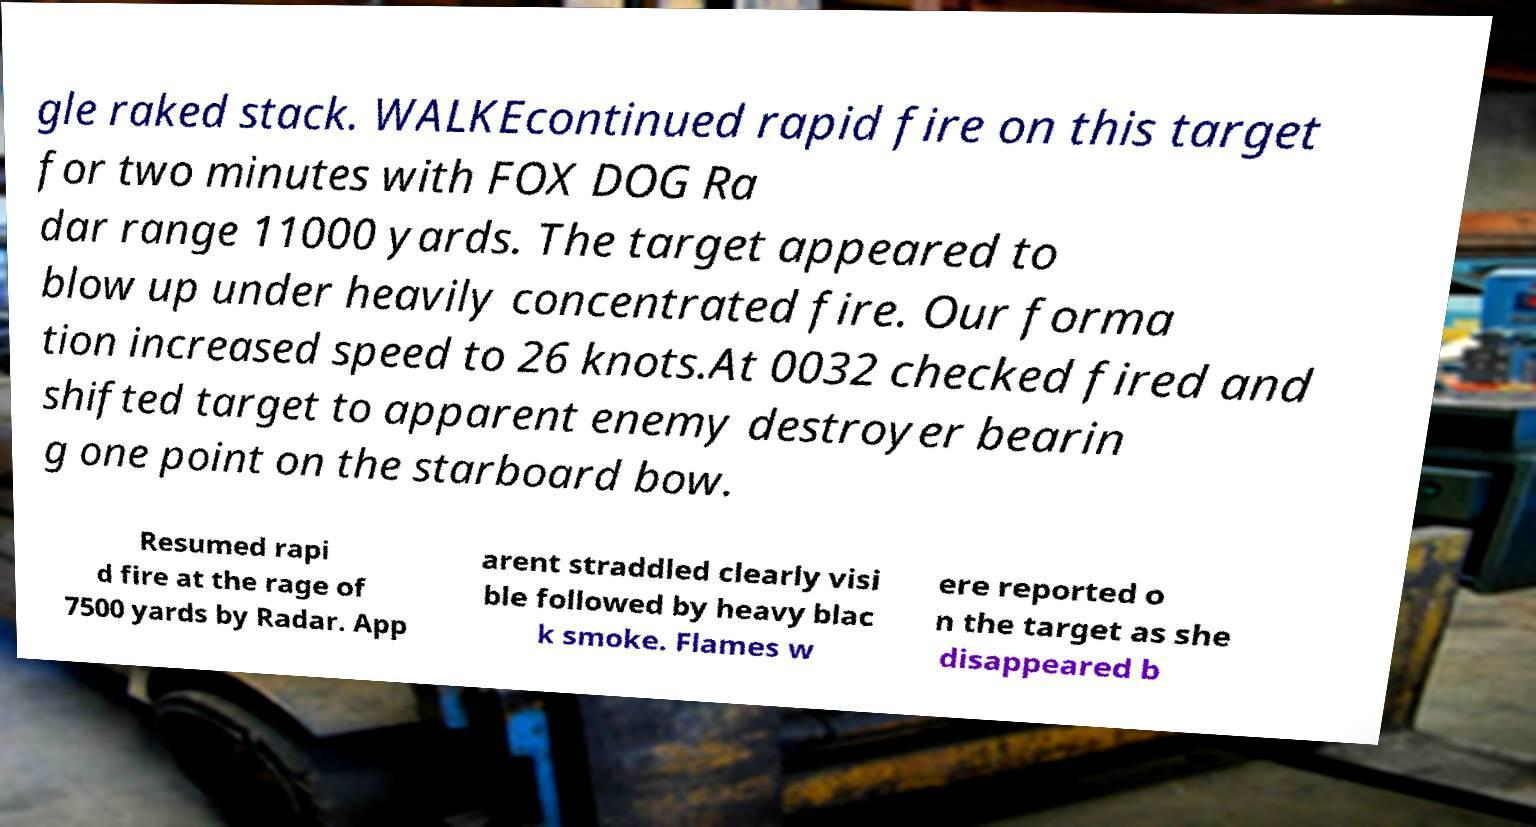There's text embedded in this image that I need extracted. Can you transcribe it verbatim? gle raked stack. WALKEcontinued rapid fire on this target for two minutes with FOX DOG Ra dar range 11000 yards. The target appeared to blow up under heavily concentrated fire. Our forma tion increased speed to 26 knots.At 0032 checked fired and shifted target to apparent enemy destroyer bearin g one point on the starboard bow. Resumed rapi d fire at the rage of 7500 yards by Radar. App arent straddled clearly visi ble followed by heavy blac k smoke. Flames w ere reported o n the target as she disappeared b 